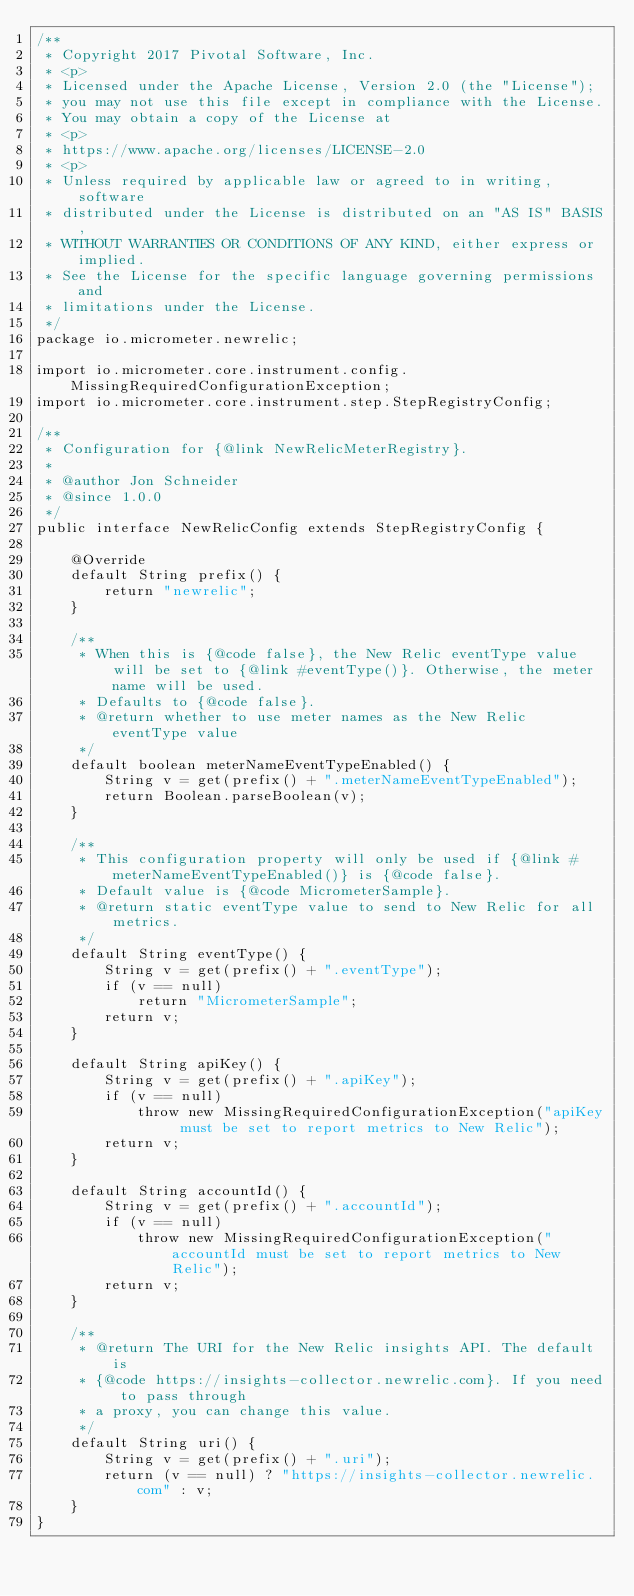<code> <loc_0><loc_0><loc_500><loc_500><_Java_>/**
 * Copyright 2017 Pivotal Software, Inc.
 * <p>
 * Licensed under the Apache License, Version 2.0 (the "License");
 * you may not use this file except in compliance with the License.
 * You may obtain a copy of the License at
 * <p>
 * https://www.apache.org/licenses/LICENSE-2.0
 * <p>
 * Unless required by applicable law or agreed to in writing, software
 * distributed under the License is distributed on an "AS IS" BASIS,
 * WITHOUT WARRANTIES OR CONDITIONS OF ANY KIND, either express or implied.
 * See the License for the specific language governing permissions and
 * limitations under the License.
 */
package io.micrometer.newrelic;

import io.micrometer.core.instrument.config.MissingRequiredConfigurationException;
import io.micrometer.core.instrument.step.StepRegistryConfig;

/**
 * Configuration for {@link NewRelicMeterRegistry}.
 *
 * @author Jon Schneider
 * @since 1.0.0
 */
public interface NewRelicConfig extends StepRegistryConfig {

    @Override
    default String prefix() {
        return "newrelic";
    }

    /**
     * When this is {@code false}, the New Relic eventType value will be set to {@link #eventType()}. Otherwise, the meter name will be used.
     * Defaults to {@code false}.
     * @return whether to use meter names as the New Relic eventType value
     */
    default boolean meterNameEventTypeEnabled() {
        String v = get(prefix() + ".meterNameEventTypeEnabled");
        return Boolean.parseBoolean(v);
    }

    /**
     * This configuration property will only be used if {@link #meterNameEventTypeEnabled()} is {@code false}.
     * Default value is {@code MicrometerSample}.
     * @return static eventType value to send to New Relic for all metrics.
     */
    default String eventType() {
        String v = get(prefix() + ".eventType");
        if (v == null)
            return "MicrometerSample";
        return v;
    }

    default String apiKey() {
        String v = get(prefix() + ".apiKey");
        if (v == null)
            throw new MissingRequiredConfigurationException("apiKey must be set to report metrics to New Relic");
        return v;
    }

    default String accountId() {
        String v = get(prefix() + ".accountId");
        if (v == null)
            throw new MissingRequiredConfigurationException("accountId must be set to report metrics to New Relic");
        return v;
    }

    /**
     * @return The URI for the New Relic insights API. The default is
     * {@code https://insights-collector.newrelic.com}. If you need to pass through
     * a proxy, you can change this value.
     */
    default String uri() {
        String v = get(prefix() + ".uri");
        return (v == null) ? "https://insights-collector.newrelic.com" : v;
    }
}
</code> 